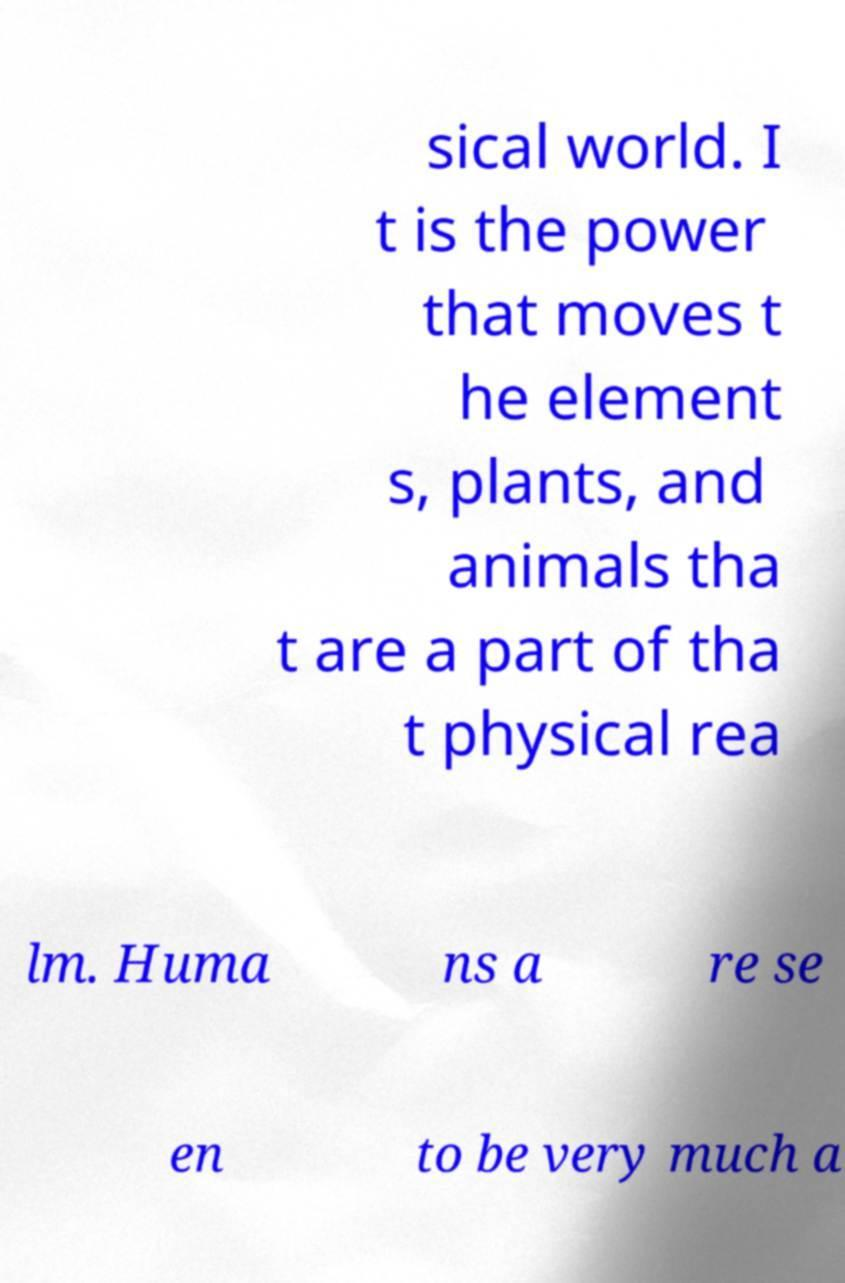For documentation purposes, I need the text within this image transcribed. Could you provide that? sical world. I t is the power that moves t he element s, plants, and animals tha t are a part of tha t physical rea lm. Huma ns a re se en to be very much a 